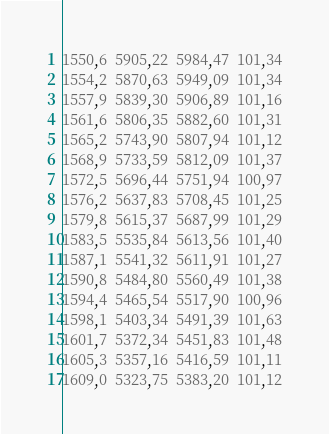<code> <loc_0><loc_0><loc_500><loc_500><_SML_>1550,6  5905,22  5984,47  101,34
1554,2  5870,63  5949,09  101,34
1557,9  5839,30  5906,89  101,16
1561,6  5806,35  5882,60  101,31
1565,2  5743,90  5807,94  101,12
1568,9  5733,59  5812,09  101,37
1572,5  5696,44  5751,94  100,97
1576,2  5637,83  5708,45  101,25
1579,8  5615,37  5687,99  101,29
1583,5  5535,84  5613,56  101,40
1587,1  5541,32  5611,91  101,27
1590,8  5484,80  5560,49  101,38
1594,4  5465,54  5517,90  100,96
1598,1  5403,34  5491,39  101,63
1601,7  5372,34  5451,83  101,48
1605,3  5357,16  5416,59  101,11
1609,0  5323,75  5383,20  101,12</code> 